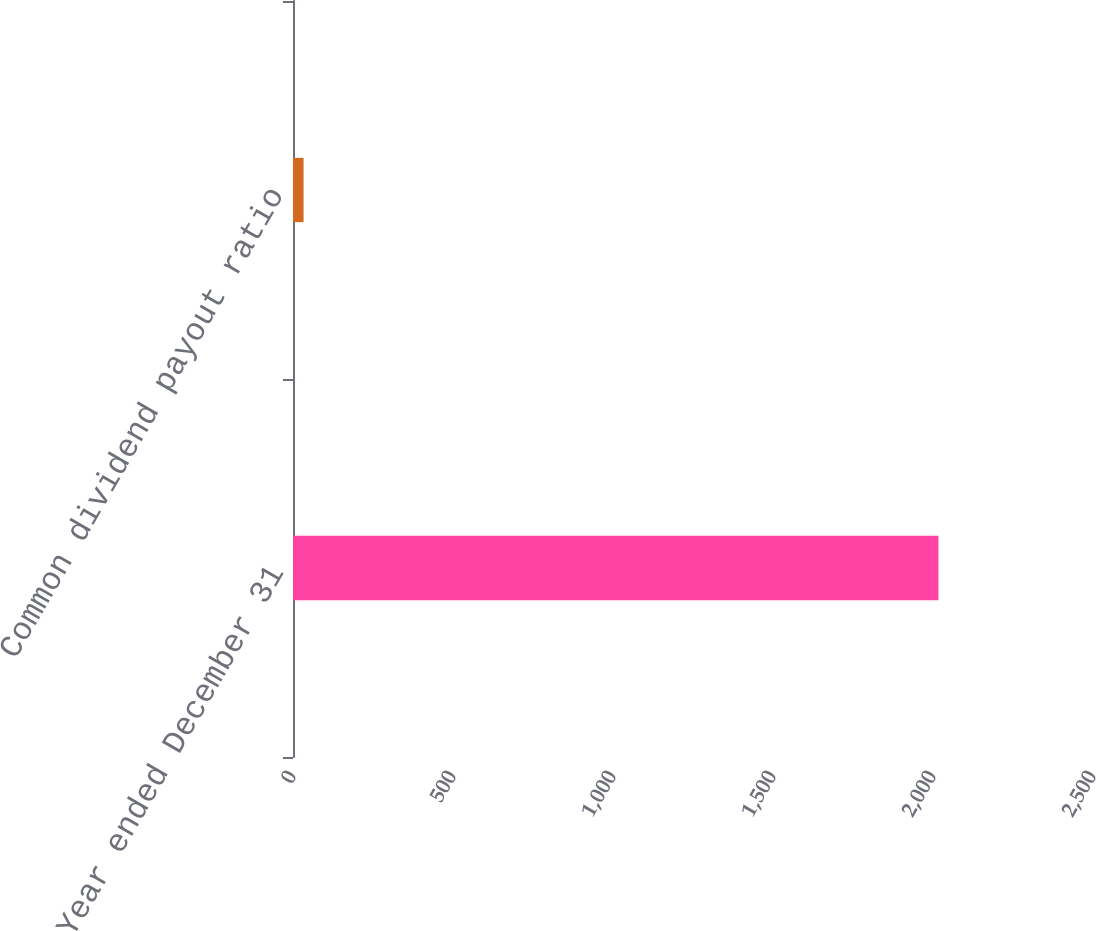Convert chart. <chart><loc_0><loc_0><loc_500><loc_500><bar_chart><fcel>Year ended December 31<fcel>Common dividend payout ratio<nl><fcel>2017<fcel>33<nl></chart> 